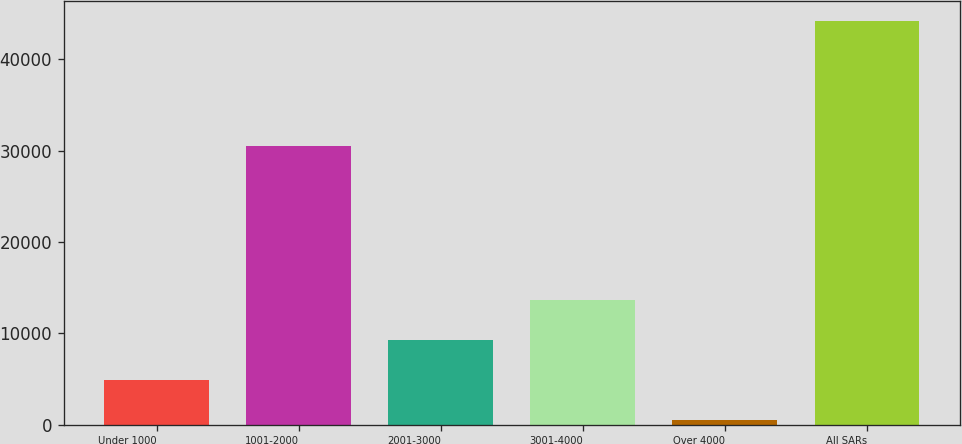Convert chart to OTSL. <chart><loc_0><loc_0><loc_500><loc_500><bar_chart><fcel>Under 1000<fcel>1001-2000<fcel>2001-3000<fcel>3001-4000<fcel>Over 4000<fcel>All SARs<nl><fcel>4936.7<fcel>30488<fcel>9291.4<fcel>13646.1<fcel>582<fcel>44129<nl></chart> 